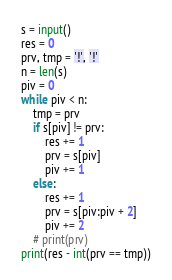Convert code to text. <code><loc_0><loc_0><loc_500><loc_500><_Python_>s = input()
res = 0
prv, tmp = '!', '!'
n = len(s)
piv = 0
while piv < n:
    tmp = prv
    if s[piv] != prv:
        res += 1
        prv = s[piv]
        piv += 1
    else:
        res += 1
        prv = s[piv:piv + 2]
        piv += 2
    # print(prv)
print(res - int(prv == tmp))</code> 